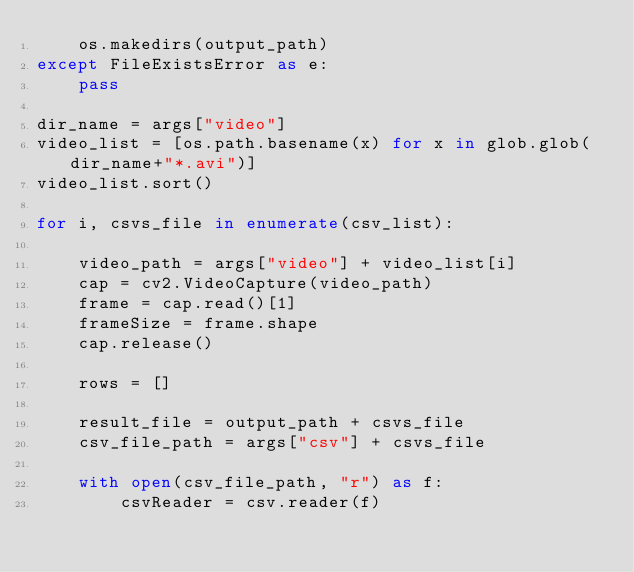<code> <loc_0><loc_0><loc_500><loc_500><_Python_>    os.makedirs(output_path)
except FileExistsError as e:
    pass

dir_name = args["video"]
video_list = [os.path.basename(x) for x in glob.glob(dir_name+"*.avi")]
video_list.sort()

for i, csvs_file in enumerate(csv_list):

    video_path = args["video"] + video_list[i]
    cap = cv2.VideoCapture(video_path)
    frame = cap.read()[1]
    frameSize = frame.shape
    cap.release()

    rows = []
    
    result_file = output_path + csvs_file
    csv_file_path = args["csv"] + csvs_file

    with open(csv_file_path, "r") as f:
        csvReader = csv.reader(f)
        </code> 